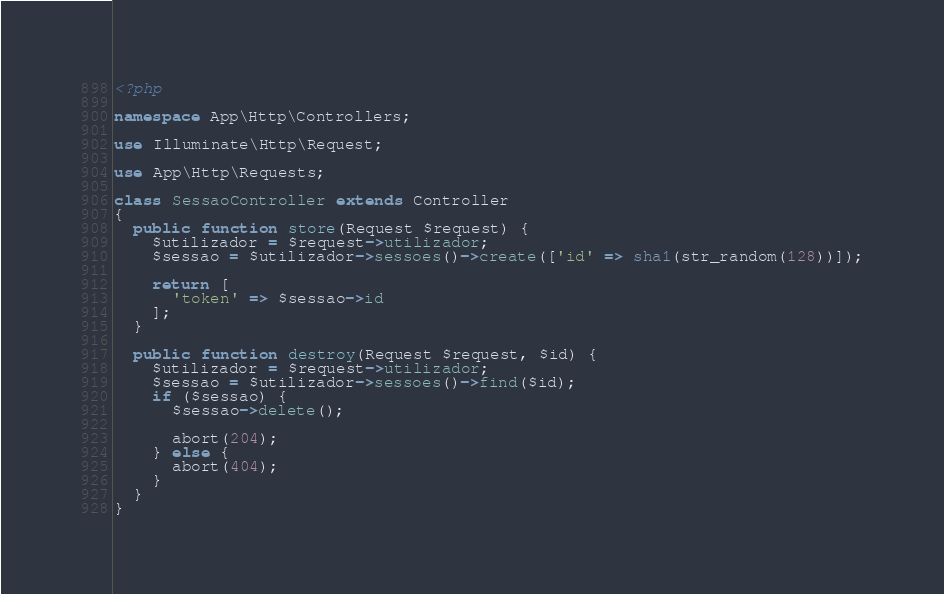<code> <loc_0><loc_0><loc_500><loc_500><_PHP_><?php

namespace App\Http\Controllers;

use Illuminate\Http\Request;

use App\Http\Requests;

class SessaoController extends Controller
{
  public function store(Request $request) {
    $utilizador = $request->utilizador;
    $sessao = $utilizador->sessoes()->create(['id' => sha1(str_random(128))]);

    return [
      'token' => $sessao->id
    ];
  }

  public function destroy(Request $request, $id) {
    $utilizador = $request->utilizador;
    $sessao = $utilizador->sessoes()->find($id);
    if ($sessao) {
      $sessao->delete();

      abort(204);
    } else {
      abort(404);
    }
  }
}
</code> 